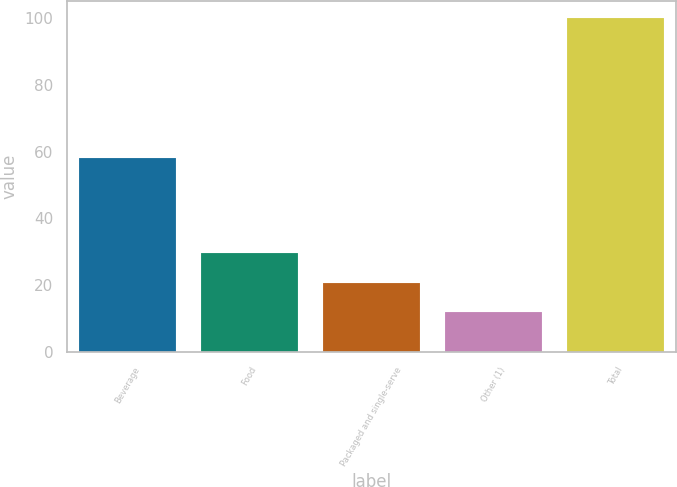Convert chart to OTSL. <chart><loc_0><loc_0><loc_500><loc_500><bar_chart><fcel>Beverage<fcel>Food<fcel>Packaged and single-serve<fcel>Other (1)<fcel>Total<nl><fcel>58<fcel>29.6<fcel>20.8<fcel>12<fcel>100<nl></chart> 